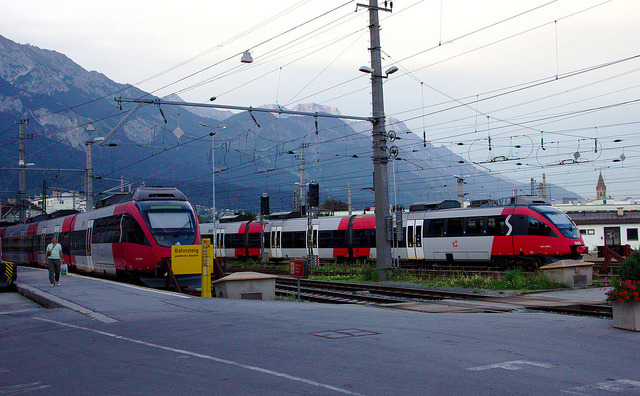How many people are walking in the photo? 1 